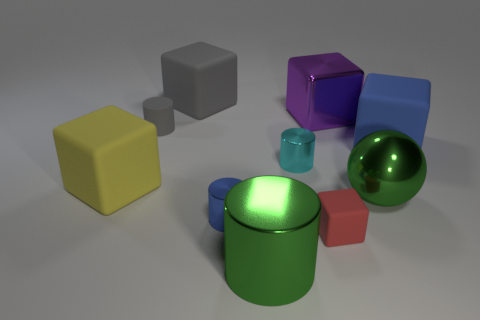Subtract all big green shiny cylinders. How many cylinders are left? 3 Subtract all yellow cubes. How many cubes are left? 4 Subtract all yellow cylinders. Subtract all green blocks. How many cylinders are left? 4 Subtract all cylinders. How many objects are left? 6 Subtract all small yellow cubes. Subtract all big yellow blocks. How many objects are left? 9 Add 1 blue cylinders. How many blue cylinders are left? 2 Add 8 big brown balls. How many big brown balls exist? 8 Subtract 0 blue spheres. How many objects are left? 10 